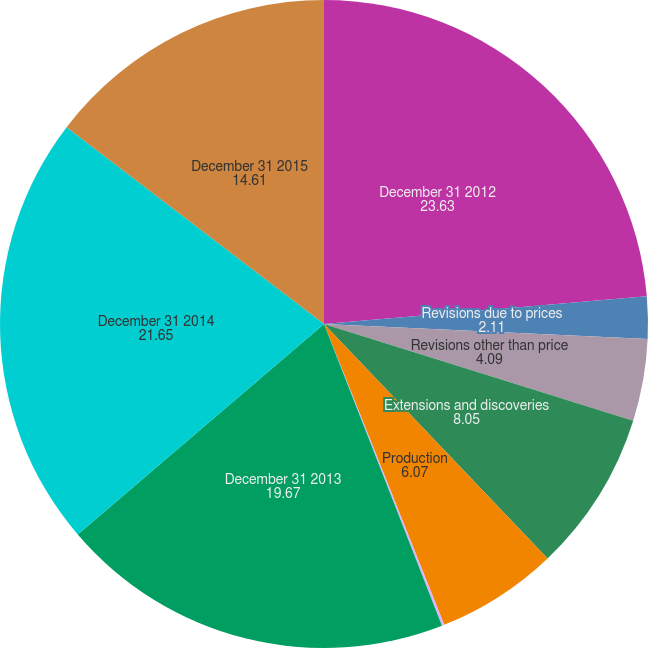<chart> <loc_0><loc_0><loc_500><loc_500><pie_chart><fcel>December 31 2012<fcel>Revisions due to prices<fcel>Revisions other than price<fcel>Extensions and discoveries<fcel>Production<fcel>Sale of reserves<fcel>December 31 2013<fcel>December 31 2014<fcel>December 31 2015<nl><fcel>23.63%<fcel>2.11%<fcel>4.09%<fcel>8.05%<fcel>6.07%<fcel>0.12%<fcel>19.67%<fcel>21.65%<fcel>14.61%<nl></chart> 